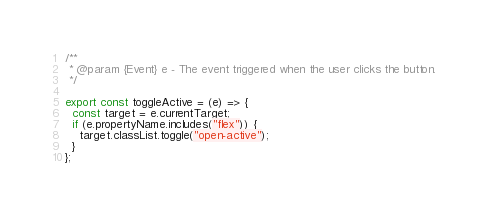<code> <loc_0><loc_0><loc_500><loc_500><_JavaScript_>/**
 * @param {Event} e - The event triggered when the user clicks the button.
 */

export const toggleActive = (e) => {
  const target = e.currentTarget;
  if (e.propertyName.includes("flex")) {
    target.classList.toggle("open-active");
  }
};
</code> 